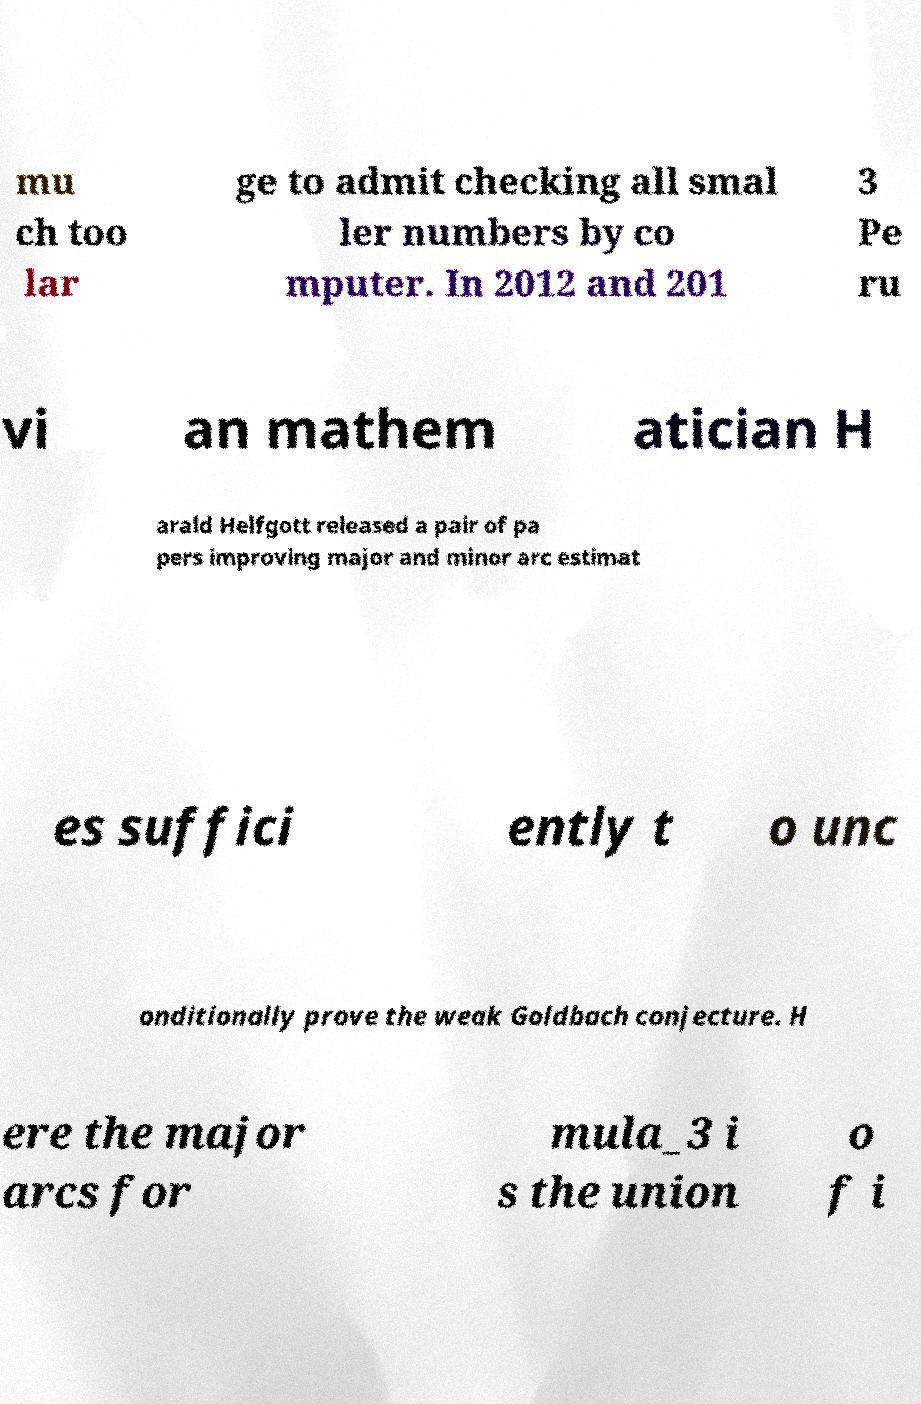Can you read and provide the text displayed in the image?This photo seems to have some interesting text. Can you extract and type it out for me? mu ch too lar ge to admit checking all smal ler numbers by co mputer. In 2012 and 201 3 Pe ru vi an mathem atician H arald Helfgott released a pair of pa pers improving major and minor arc estimat es suffici ently t o unc onditionally prove the weak Goldbach conjecture. H ere the major arcs for mula_3 i s the union o f i 